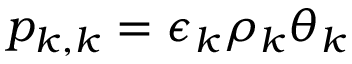Convert formula to latex. <formula><loc_0><loc_0><loc_500><loc_500>p _ { k , k } = \epsilon _ { k } \rho _ { k } \theta _ { k }</formula> 